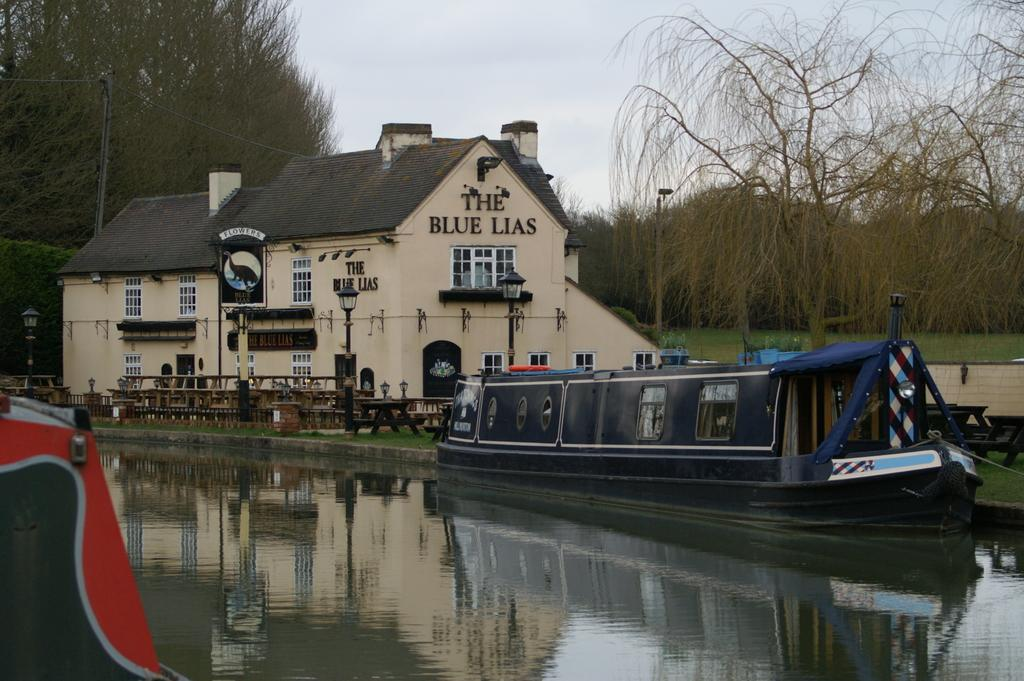What color is the boat in the image? The boat in the image is black. Where is the boat located in relation to the water? The boat is on water in the image. In which corner of the image is the boat situated? The boat is in the right corner of the image. What can be seen in the background of the image? There is a building and trees in the background of the image. What type of glue is being used to hold the bells together in the image? There are no bells or glue present in the image; it features a black boat on water with a building and trees in the background. 